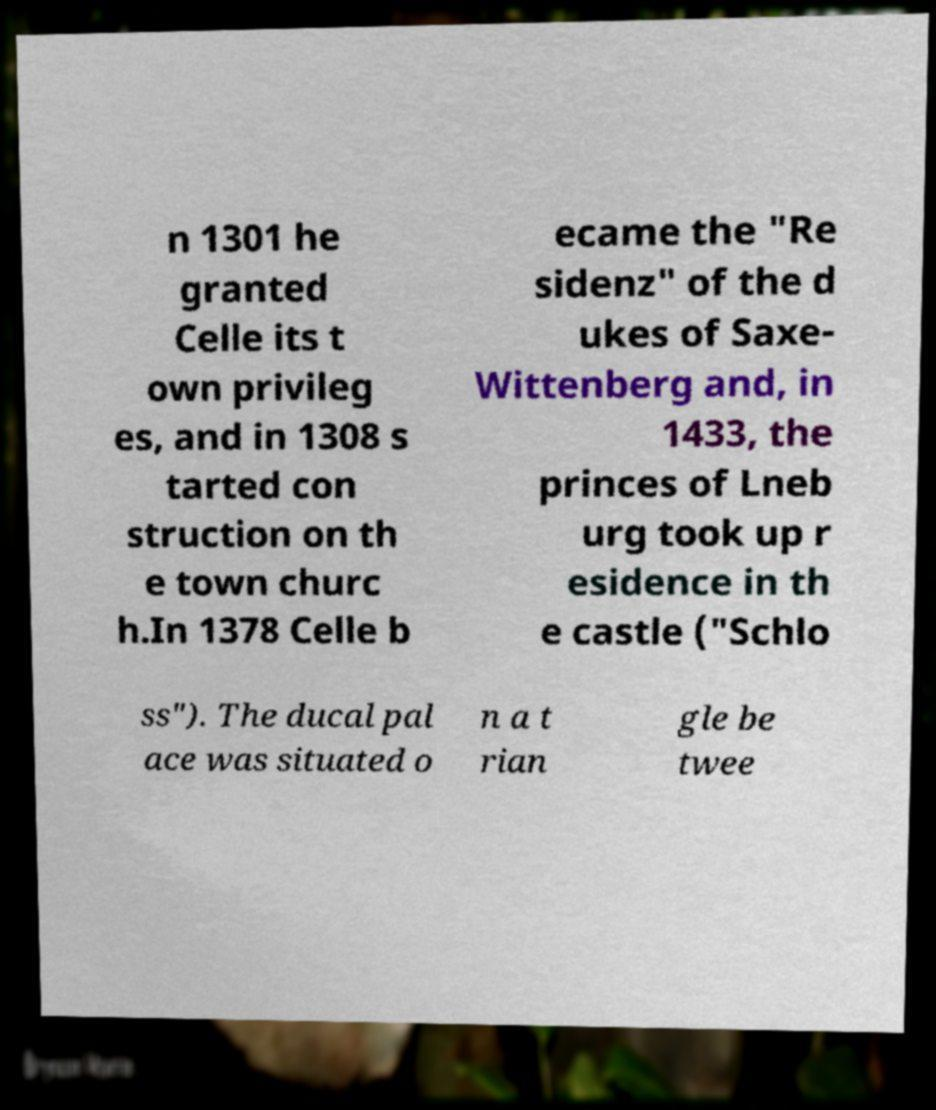What messages or text are displayed in this image? I need them in a readable, typed format. n 1301 he granted Celle its t own privileg es, and in 1308 s tarted con struction on th e town churc h.In 1378 Celle b ecame the "Re sidenz" of the d ukes of Saxe- Wittenberg and, in 1433, the princes of Lneb urg took up r esidence in th e castle ("Schlo ss"). The ducal pal ace was situated o n a t rian gle be twee 